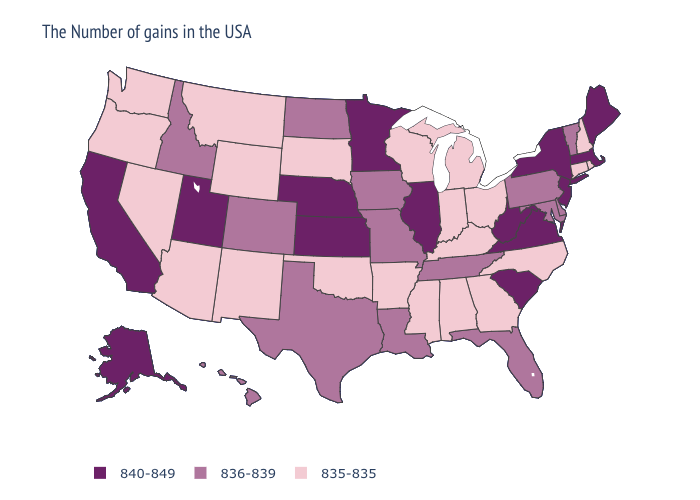Does Mississippi have the lowest value in the USA?
Keep it brief. Yes. Name the states that have a value in the range 836-839?
Keep it brief. Vermont, Delaware, Maryland, Pennsylvania, Florida, Tennessee, Louisiana, Missouri, Iowa, Texas, North Dakota, Colorado, Idaho, Hawaii. What is the value of Nebraska?
Keep it brief. 840-849. Does Pennsylvania have a higher value than Utah?
Be succinct. No. Is the legend a continuous bar?
Be succinct. No. Is the legend a continuous bar?
Give a very brief answer. No. What is the lowest value in the USA?
Give a very brief answer. 835-835. What is the value of Colorado?
Short answer required. 836-839. Name the states that have a value in the range 836-839?
Write a very short answer. Vermont, Delaware, Maryland, Pennsylvania, Florida, Tennessee, Louisiana, Missouri, Iowa, Texas, North Dakota, Colorado, Idaho, Hawaii. Among the states that border New Hampshire , which have the highest value?
Short answer required. Maine, Massachusetts. What is the highest value in the USA?
Write a very short answer. 840-849. What is the lowest value in the MidWest?
Keep it brief. 835-835. Name the states that have a value in the range 840-849?
Concise answer only. Maine, Massachusetts, New York, New Jersey, Virginia, South Carolina, West Virginia, Illinois, Minnesota, Kansas, Nebraska, Utah, California, Alaska. 